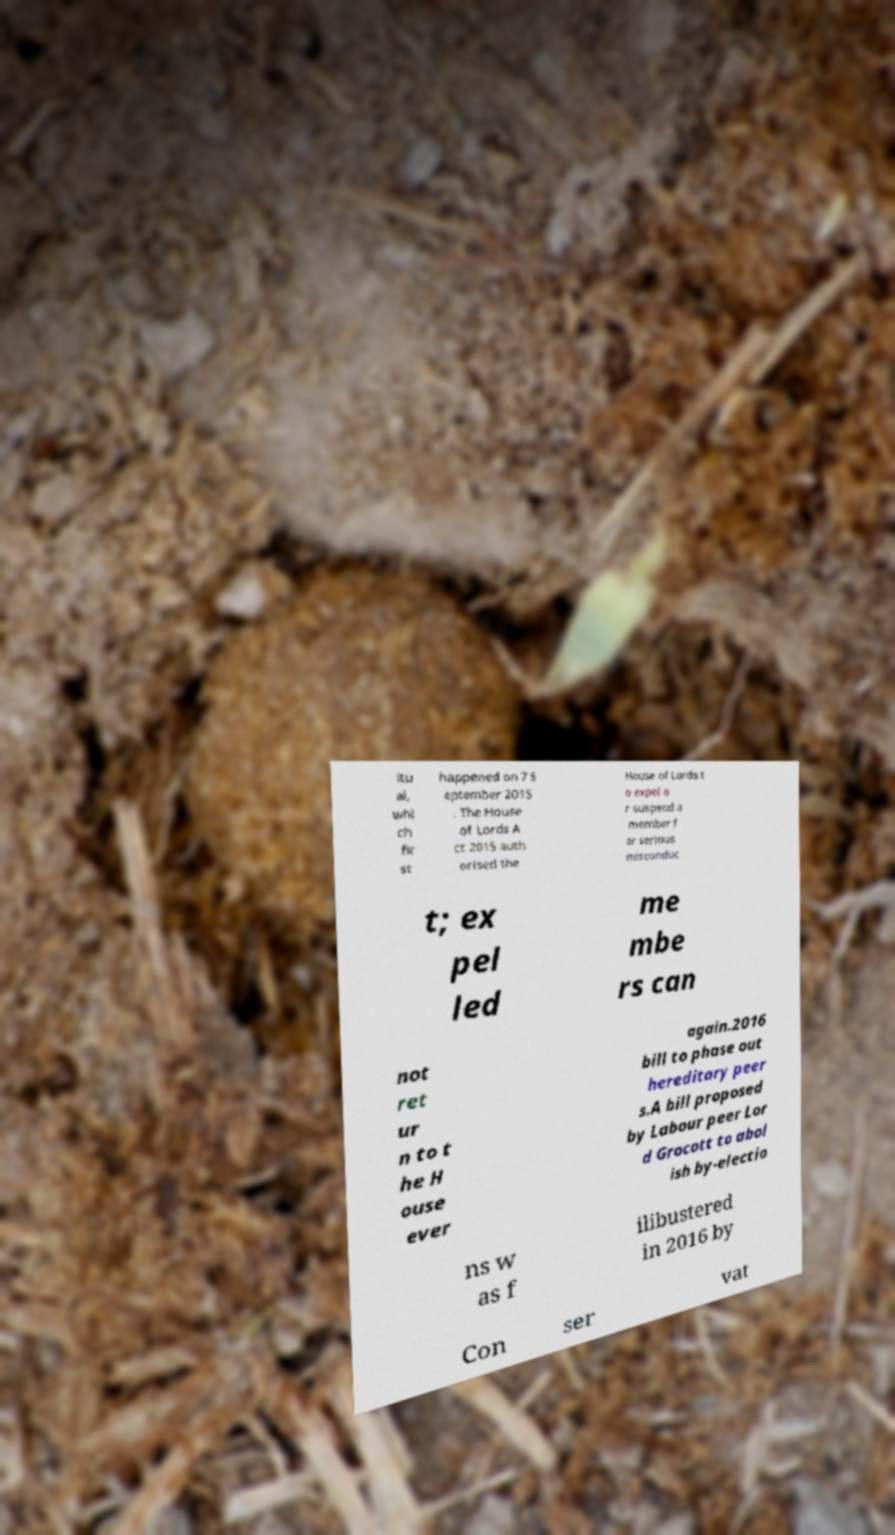There's text embedded in this image that I need extracted. Can you transcribe it verbatim? itu al, whi ch fir st happened on 7 S eptember 2015 . The House of Lords A ct 2015 auth orised the House of Lords t o expel o r suspend a member f or serious misconduc t; ex pel led me mbe rs can not ret ur n to t he H ouse ever again.2016 bill to phase out hereditary peer s.A bill proposed by Labour peer Lor d Grocott to abol ish by-electio ns w as f ilibustered in 2016 by Con ser vat 